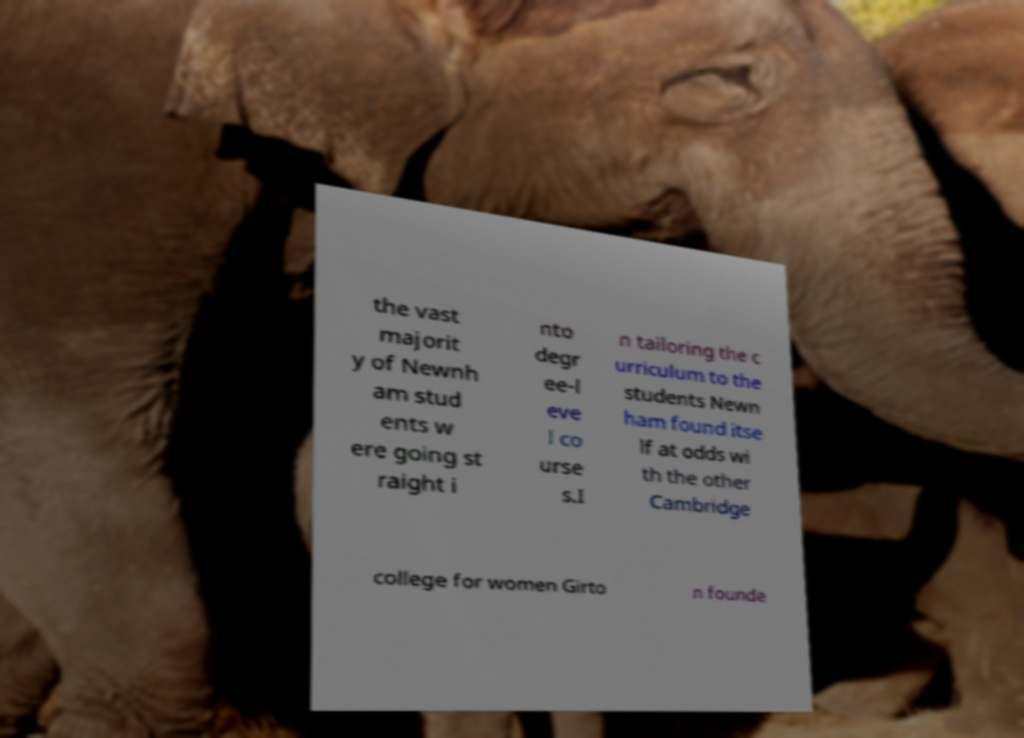Please read and relay the text visible in this image. What does it say? the vast majorit y of Newnh am stud ents w ere going st raight i nto degr ee-l eve l co urse s.I n tailoring the c urriculum to the students Newn ham found itse lf at odds wi th the other Cambridge college for women Girto n founde 